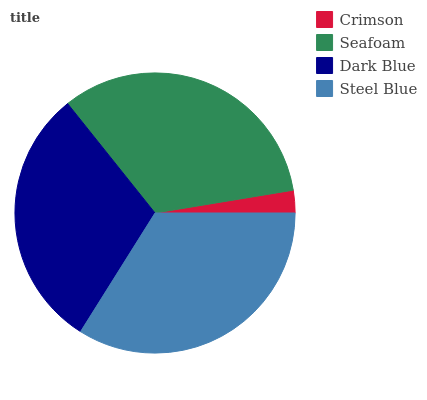Is Crimson the minimum?
Answer yes or no. Yes. Is Steel Blue the maximum?
Answer yes or no. Yes. Is Seafoam the minimum?
Answer yes or no. No. Is Seafoam the maximum?
Answer yes or no. No. Is Seafoam greater than Crimson?
Answer yes or no. Yes. Is Crimson less than Seafoam?
Answer yes or no. Yes. Is Crimson greater than Seafoam?
Answer yes or no. No. Is Seafoam less than Crimson?
Answer yes or no. No. Is Seafoam the high median?
Answer yes or no. Yes. Is Dark Blue the low median?
Answer yes or no. Yes. Is Steel Blue the high median?
Answer yes or no. No. Is Steel Blue the low median?
Answer yes or no. No. 